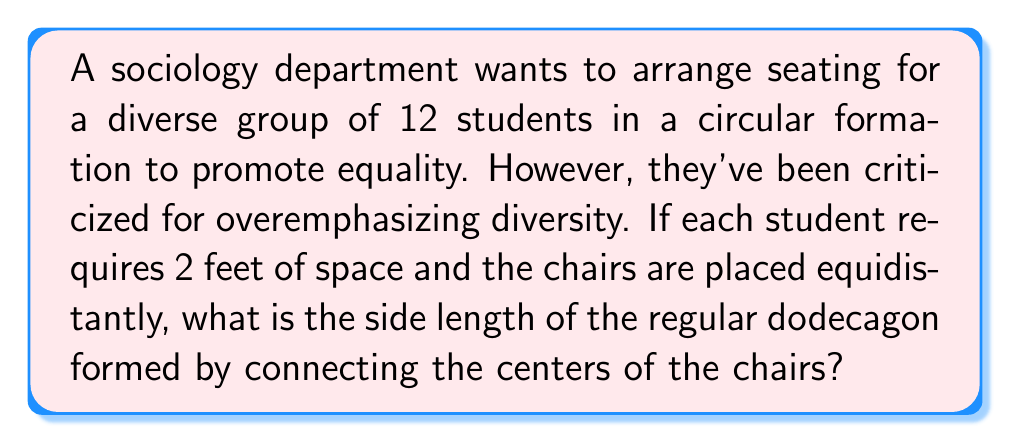Provide a solution to this math problem. Let's approach this step-by-step:

1) First, we need to calculate the circumference of the circle:
   Circumference = Number of students × Space per student
   $C = 12 \times 2 = 24$ feet

2) Now, we can find the radius of this circle:
   $C = 2\pi r$
   $24 = 2\pi r$
   $r = \frac{24}{2\pi} = \frac{12}{\pi}$ feet

3) The chairs form a regular dodecagon. In a regular polygon, the length of a side is related to the radius of the circumscribed circle by the formula:
   $s = 2r \sin(\frac{\pi}{n})$

   Where:
   $s$ is the side length
   $r$ is the radius
   $n$ is the number of sides (12 in this case)

4) Substituting our values:
   $s = 2 \cdot \frac{12}{\pi} \cdot \sin(\frac{\pi}{12})$

5) Simplifying:
   $s = \frac{24}{\pi} \cdot \sin(\frac{\pi}{12})$

6) Using a calculator or leaving it in this exact form:
   $s \approx 3.13$ feet

This arrangement ensures equal spacing without explicitly mentioning diversity, addressing the persona's concerns.
Answer: $\frac{24}{\pi} \cdot \sin(\frac{\pi}{12})$ feet 